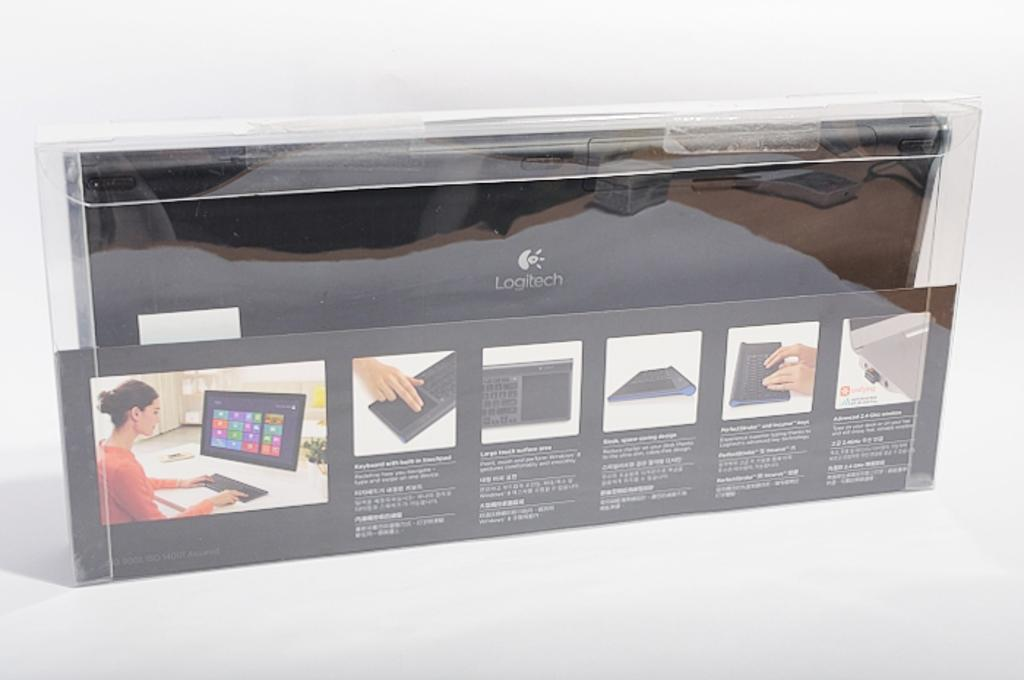<image>
Share a concise interpretation of the image provided. a wireless keyboard in a pack that is labeled 'logitech' 